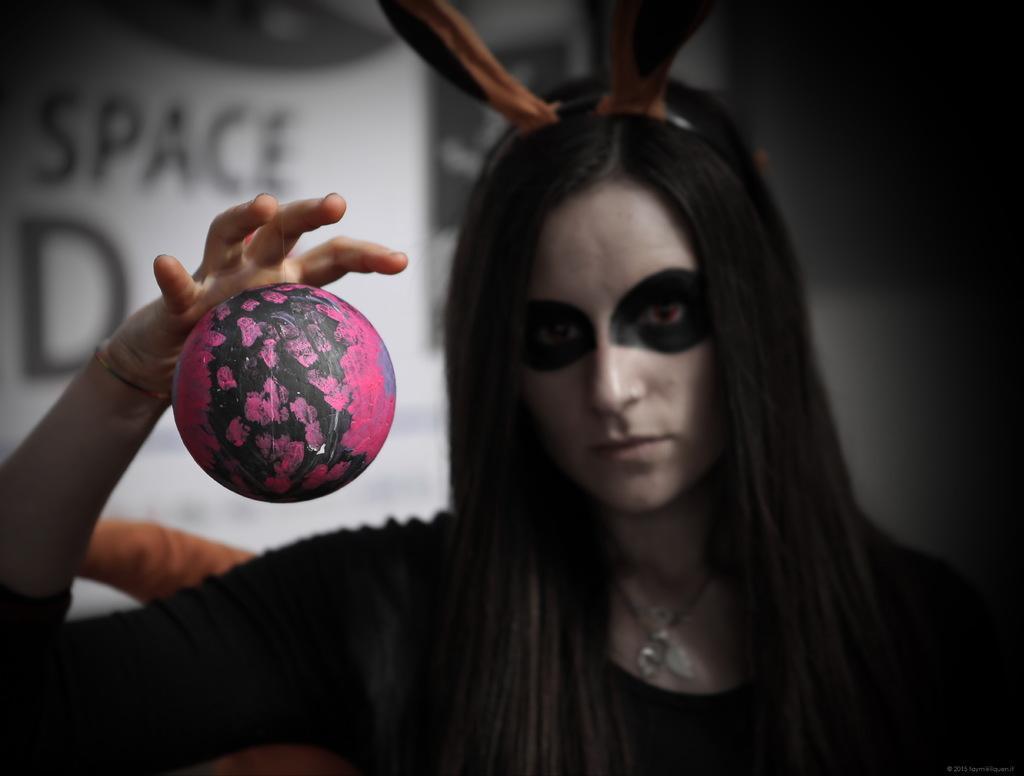How would you summarize this image in a sentence or two? In this picture I can see a woman, the woman is wearing black color dress. Here I can see a round object. In the background I can see a wall and white color object on which something written on it. 